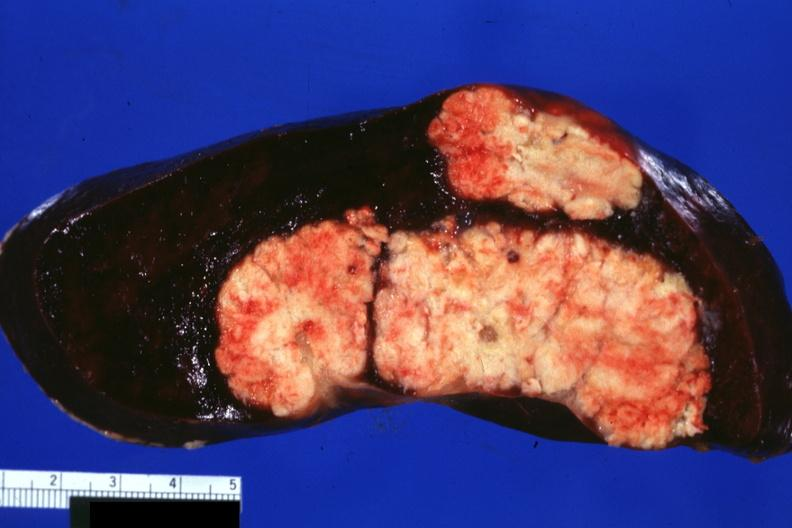what is present?
Answer the question using a single word or phrase. Hematologic 